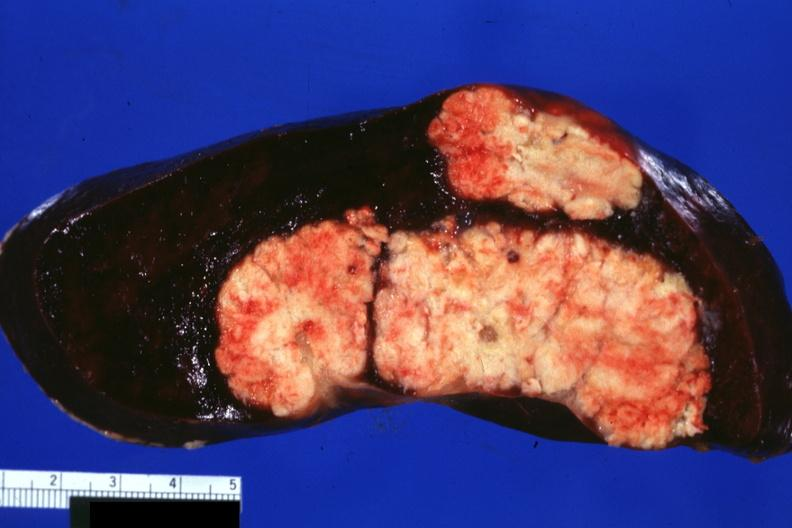what is present?
Answer the question using a single word or phrase. Hematologic 